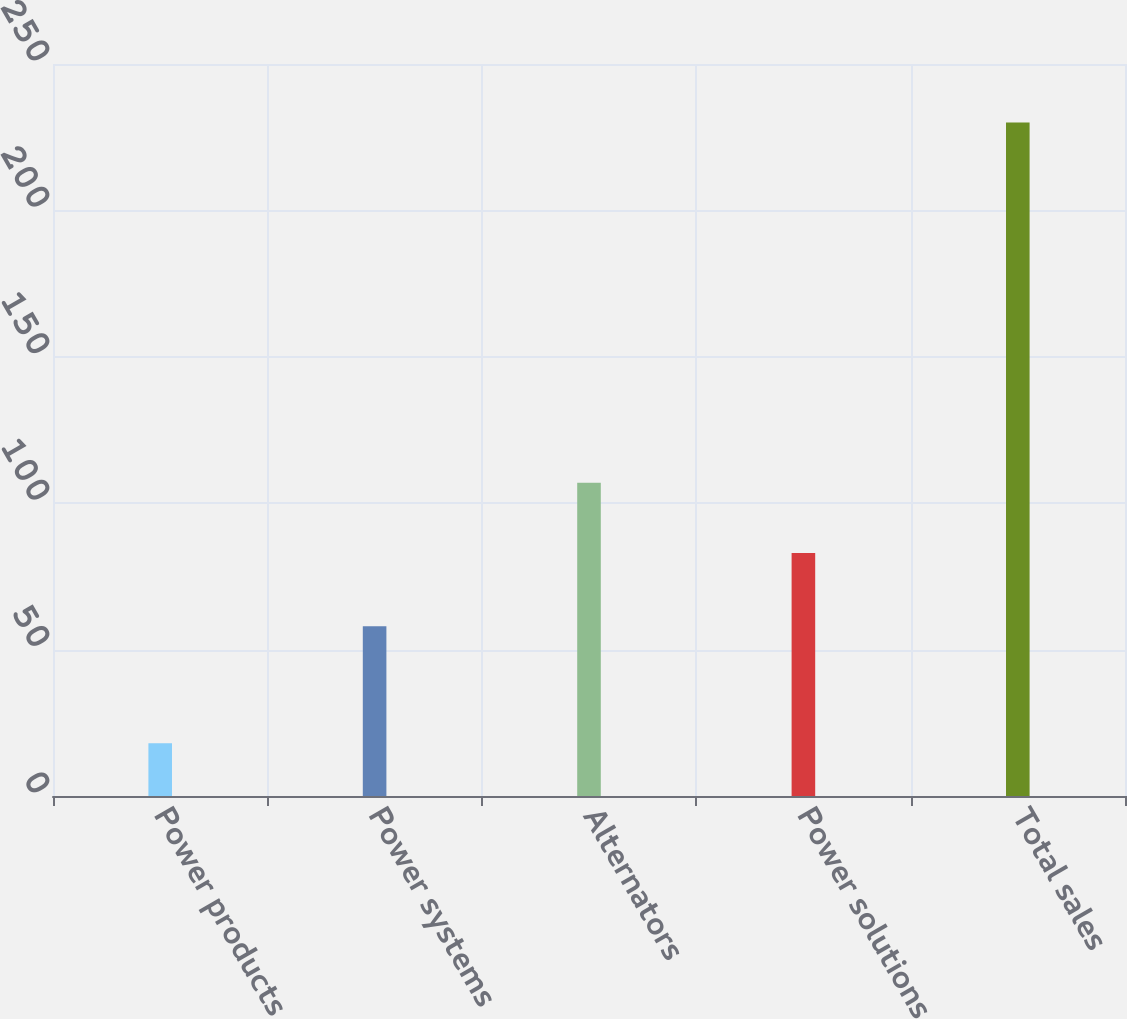Convert chart. <chart><loc_0><loc_0><loc_500><loc_500><bar_chart><fcel>Power products<fcel>Power systems<fcel>Alternators<fcel>Power solutions<fcel>Total sales<nl><fcel>18<fcel>58<fcel>107<fcel>83<fcel>230<nl></chart> 